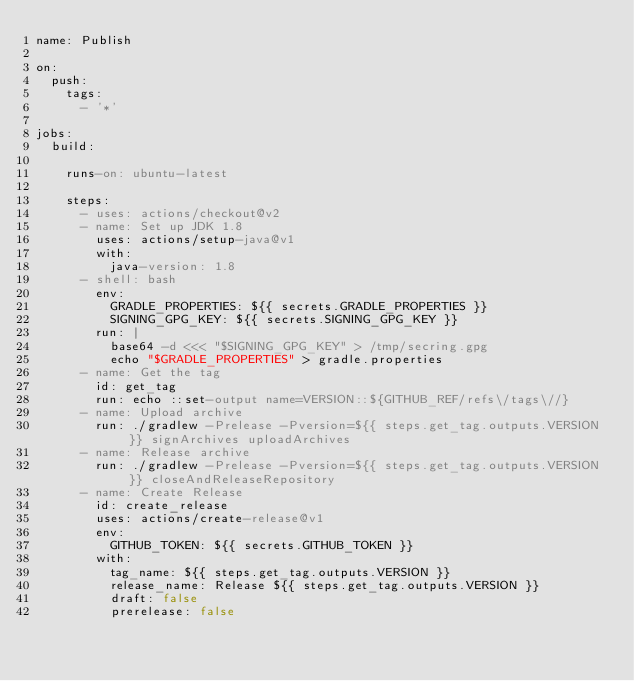Convert code to text. <code><loc_0><loc_0><loc_500><loc_500><_YAML_>name: Publish

on:
  push:
    tags:
      - '*'

jobs:
  build:

    runs-on: ubuntu-latest

    steps:
      - uses: actions/checkout@v2
      - name: Set up JDK 1.8
        uses: actions/setup-java@v1
        with:
          java-version: 1.8
      - shell: bash
        env:
          GRADLE_PROPERTIES: ${{ secrets.GRADLE_PROPERTIES }}
          SIGNING_GPG_KEY: ${{ secrets.SIGNING_GPG_KEY }}
        run: |
          base64 -d <<< "$SIGNING_GPG_KEY" > /tmp/secring.gpg
          echo "$GRADLE_PROPERTIES" > gradle.properties
      - name: Get the tag
        id: get_tag
        run: echo ::set-output name=VERSION::${GITHUB_REF/refs\/tags\//}
      - name: Upload archive
        run: ./gradlew -Prelease -Pversion=${{ steps.get_tag.outputs.VERSION }} signArchives uploadArchives
      - name: Release archive
        run: ./gradlew -Prelease -Pversion=${{ steps.get_tag.outputs.VERSION }} closeAndReleaseRepository
      - name: Create Release
        id: create_release
        uses: actions/create-release@v1
        env:
          GITHUB_TOKEN: ${{ secrets.GITHUB_TOKEN }}
        with:
          tag_name: ${{ steps.get_tag.outputs.VERSION }}
          release_name: Release ${{ steps.get_tag.outputs.VERSION }}
          draft: false
          prerelease: false</code> 